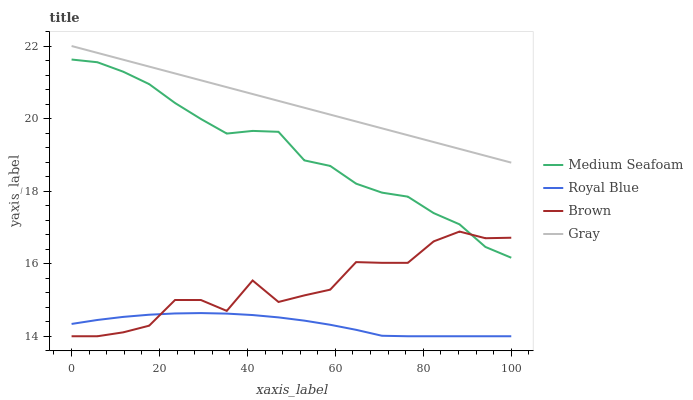Does Royal Blue have the minimum area under the curve?
Answer yes or no. Yes. Does Gray have the maximum area under the curve?
Answer yes or no. Yes. Does Medium Seafoam have the minimum area under the curve?
Answer yes or no. No. Does Medium Seafoam have the maximum area under the curve?
Answer yes or no. No. Is Gray the smoothest?
Answer yes or no. Yes. Is Brown the roughest?
Answer yes or no. Yes. Is Medium Seafoam the smoothest?
Answer yes or no. No. Is Medium Seafoam the roughest?
Answer yes or no. No. Does Royal Blue have the lowest value?
Answer yes or no. Yes. Does Medium Seafoam have the lowest value?
Answer yes or no. No. Does Gray have the highest value?
Answer yes or no. Yes. Does Medium Seafoam have the highest value?
Answer yes or no. No. Is Royal Blue less than Medium Seafoam?
Answer yes or no. Yes. Is Gray greater than Medium Seafoam?
Answer yes or no. Yes. Does Brown intersect Royal Blue?
Answer yes or no. Yes. Is Brown less than Royal Blue?
Answer yes or no. No. Is Brown greater than Royal Blue?
Answer yes or no. No. Does Royal Blue intersect Medium Seafoam?
Answer yes or no. No. 